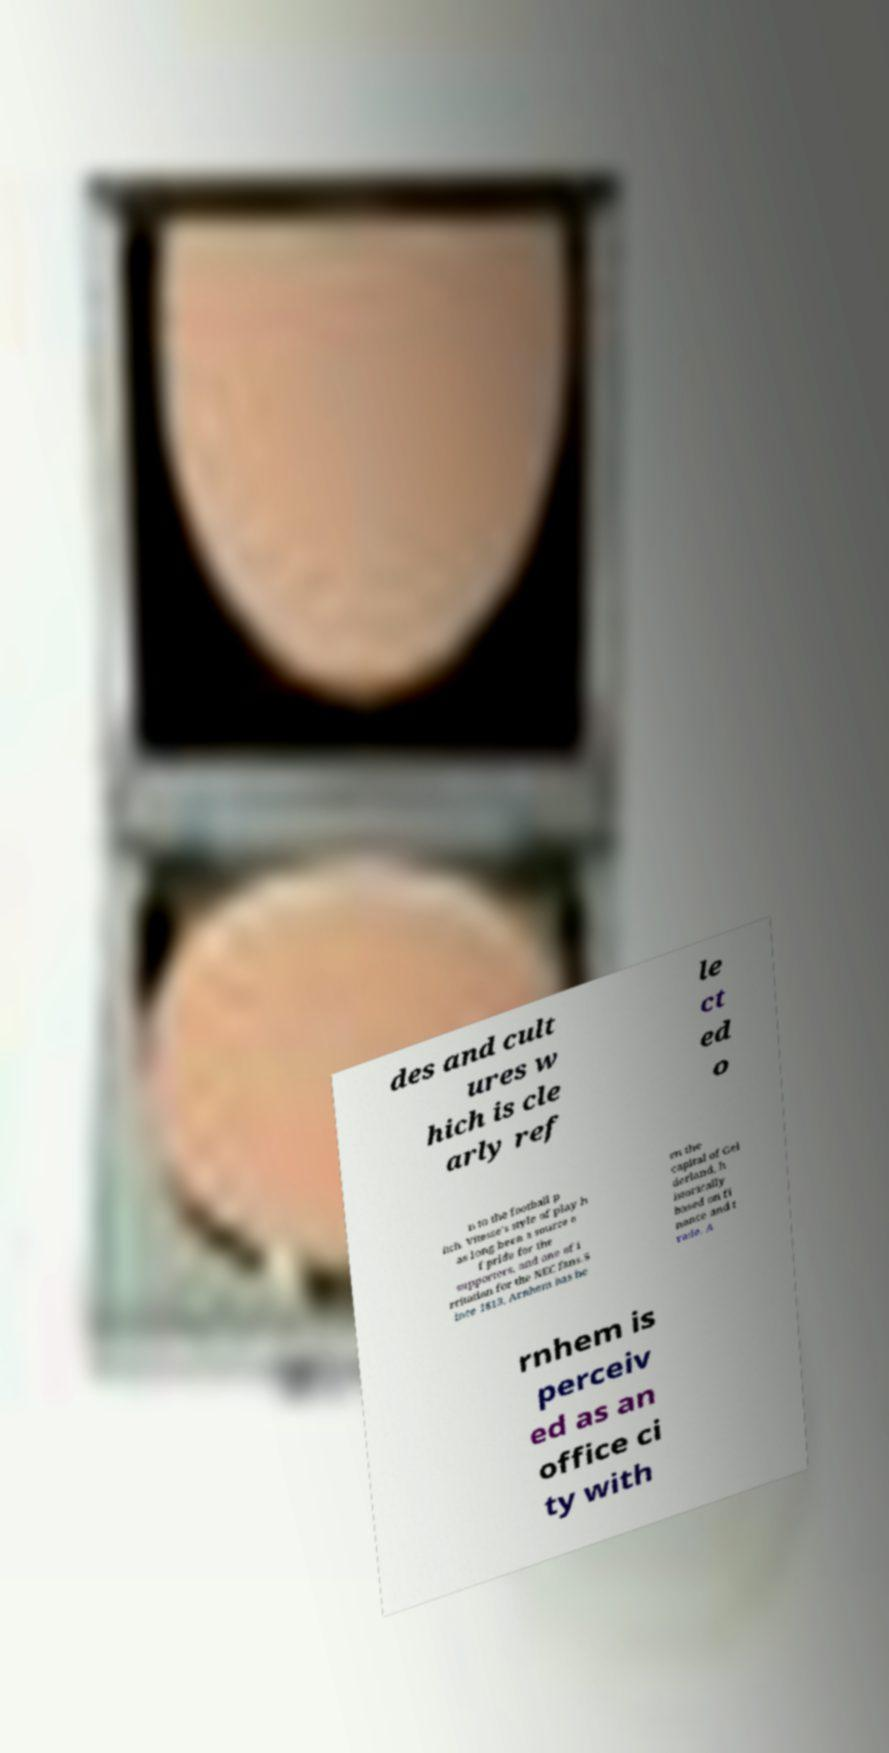For documentation purposes, I need the text within this image transcribed. Could you provide that? des and cult ures w hich is cle arly ref le ct ed o n to the football p itch. Vitesse's style of play h as long been a source o f pride for the supporters, and one of i rritation for the NEC fans.S ince 1813, Arnhem has be en the capital of Gel derland, h istorically based on fi nance and t rade. A rnhem is perceiv ed as an office ci ty with 